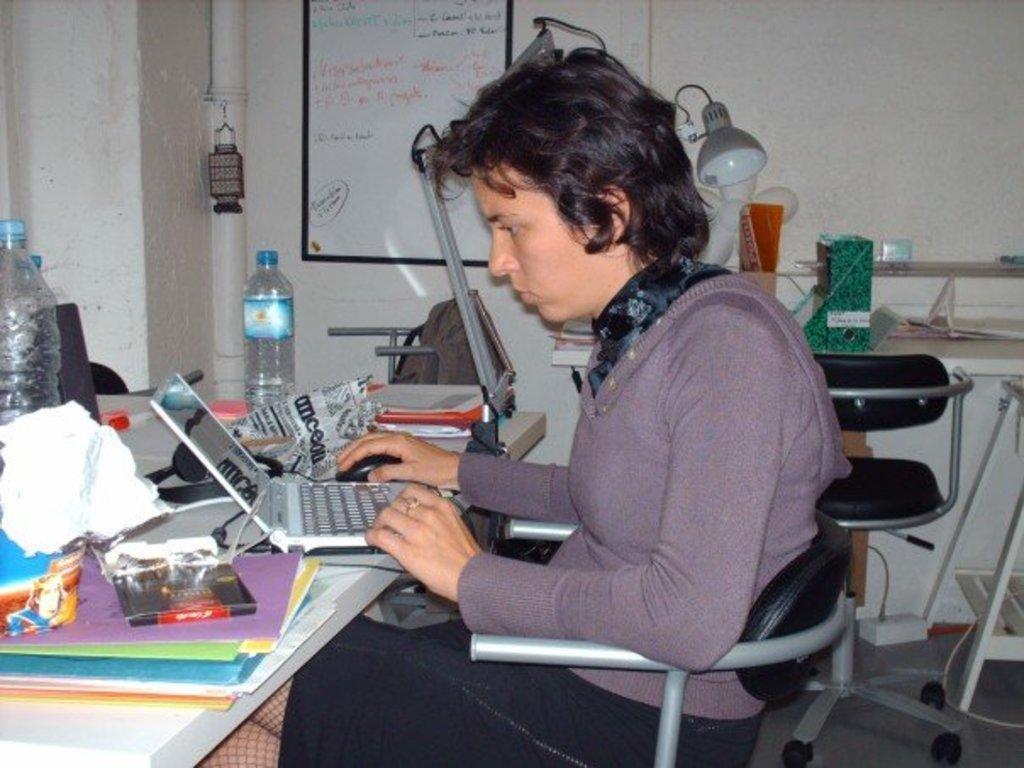In one or two sentences, can you explain what this image depicts? In this image there is a woman sitting on the chair, in front of her there is a table with laptop, books, papers, water bottles and some other objects are placed on top of it, beside the table there is another chair and table with some objects and the lamp on top of it. In the background there is a board with some text, beside the board there is an object hanging on the pipe which is attached to the wall. 